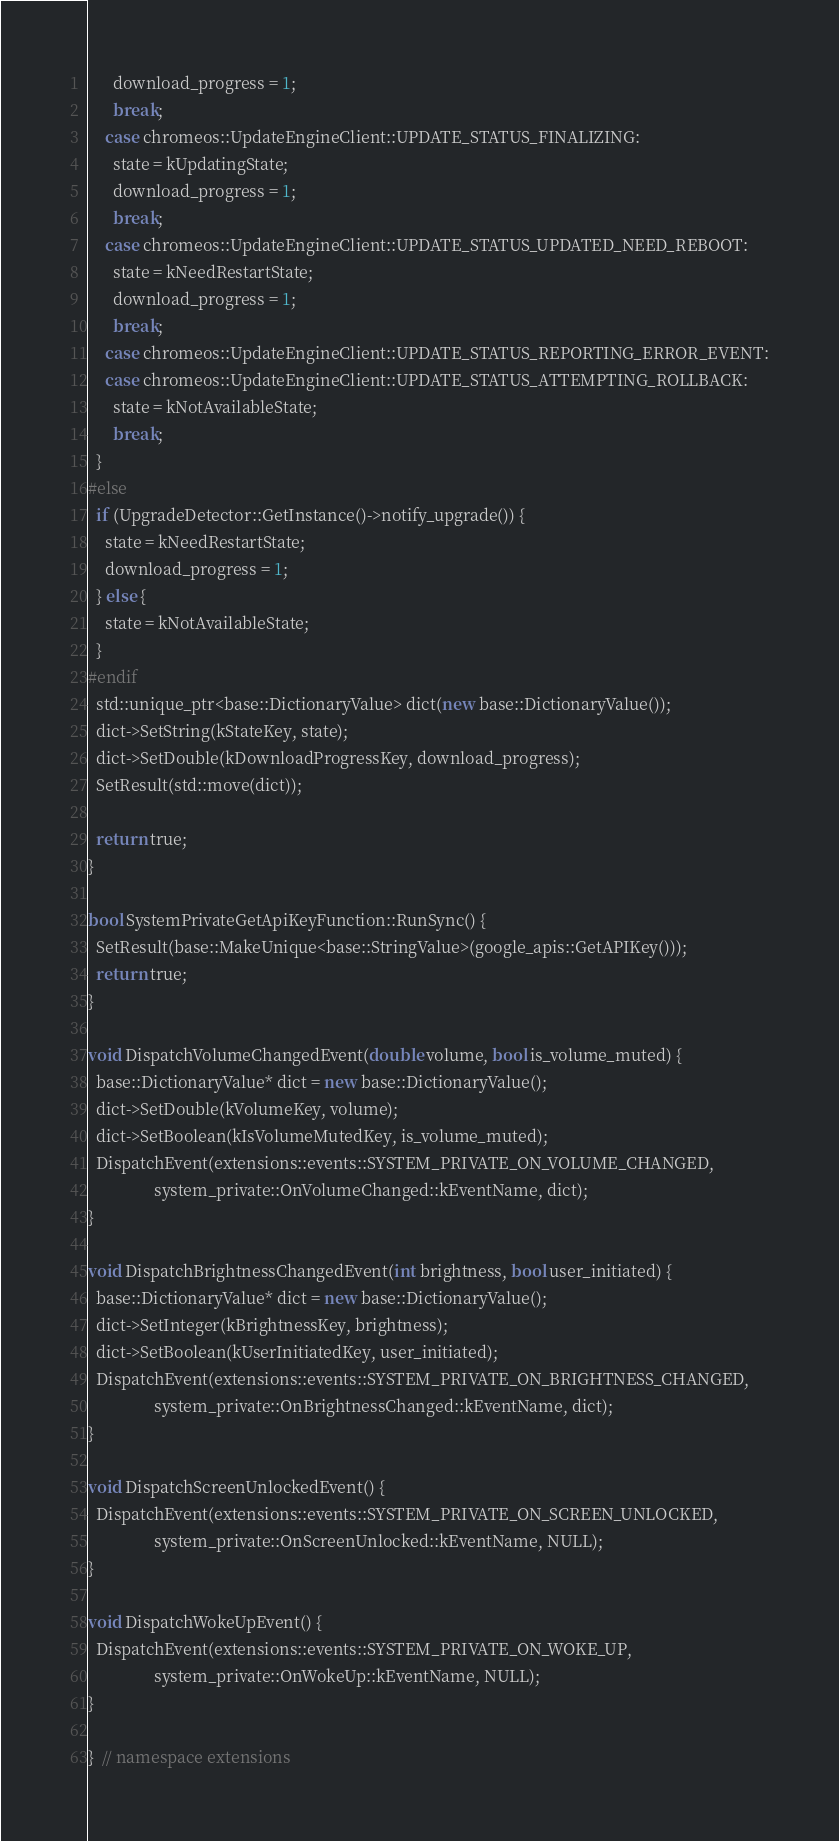<code> <loc_0><loc_0><loc_500><loc_500><_C++_>      download_progress = 1;
      break;
    case chromeos::UpdateEngineClient::UPDATE_STATUS_FINALIZING:
      state = kUpdatingState;
      download_progress = 1;
      break;
    case chromeos::UpdateEngineClient::UPDATE_STATUS_UPDATED_NEED_REBOOT:
      state = kNeedRestartState;
      download_progress = 1;
      break;
    case chromeos::UpdateEngineClient::UPDATE_STATUS_REPORTING_ERROR_EVENT:
    case chromeos::UpdateEngineClient::UPDATE_STATUS_ATTEMPTING_ROLLBACK:
      state = kNotAvailableState;
      break;
  }
#else
  if (UpgradeDetector::GetInstance()->notify_upgrade()) {
    state = kNeedRestartState;
    download_progress = 1;
  } else {
    state = kNotAvailableState;
  }
#endif
  std::unique_ptr<base::DictionaryValue> dict(new base::DictionaryValue());
  dict->SetString(kStateKey, state);
  dict->SetDouble(kDownloadProgressKey, download_progress);
  SetResult(std::move(dict));

  return true;
}

bool SystemPrivateGetApiKeyFunction::RunSync() {
  SetResult(base::MakeUnique<base::StringValue>(google_apis::GetAPIKey()));
  return true;
}

void DispatchVolumeChangedEvent(double volume, bool is_volume_muted) {
  base::DictionaryValue* dict = new base::DictionaryValue();
  dict->SetDouble(kVolumeKey, volume);
  dict->SetBoolean(kIsVolumeMutedKey, is_volume_muted);
  DispatchEvent(extensions::events::SYSTEM_PRIVATE_ON_VOLUME_CHANGED,
                system_private::OnVolumeChanged::kEventName, dict);
}

void DispatchBrightnessChangedEvent(int brightness, bool user_initiated) {
  base::DictionaryValue* dict = new base::DictionaryValue();
  dict->SetInteger(kBrightnessKey, brightness);
  dict->SetBoolean(kUserInitiatedKey, user_initiated);
  DispatchEvent(extensions::events::SYSTEM_PRIVATE_ON_BRIGHTNESS_CHANGED,
                system_private::OnBrightnessChanged::kEventName, dict);
}

void DispatchScreenUnlockedEvent() {
  DispatchEvent(extensions::events::SYSTEM_PRIVATE_ON_SCREEN_UNLOCKED,
                system_private::OnScreenUnlocked::kEventName, NULL);
}

void DispatchWokeUpEvent() {
  DispatchEvent(extensions::events::SYSTEM_PRIVATE_ON_WOKE_UP,
                system_private::OnWokeUp::kEventName, NULL);
}

}  // namespace extensions
</code> 